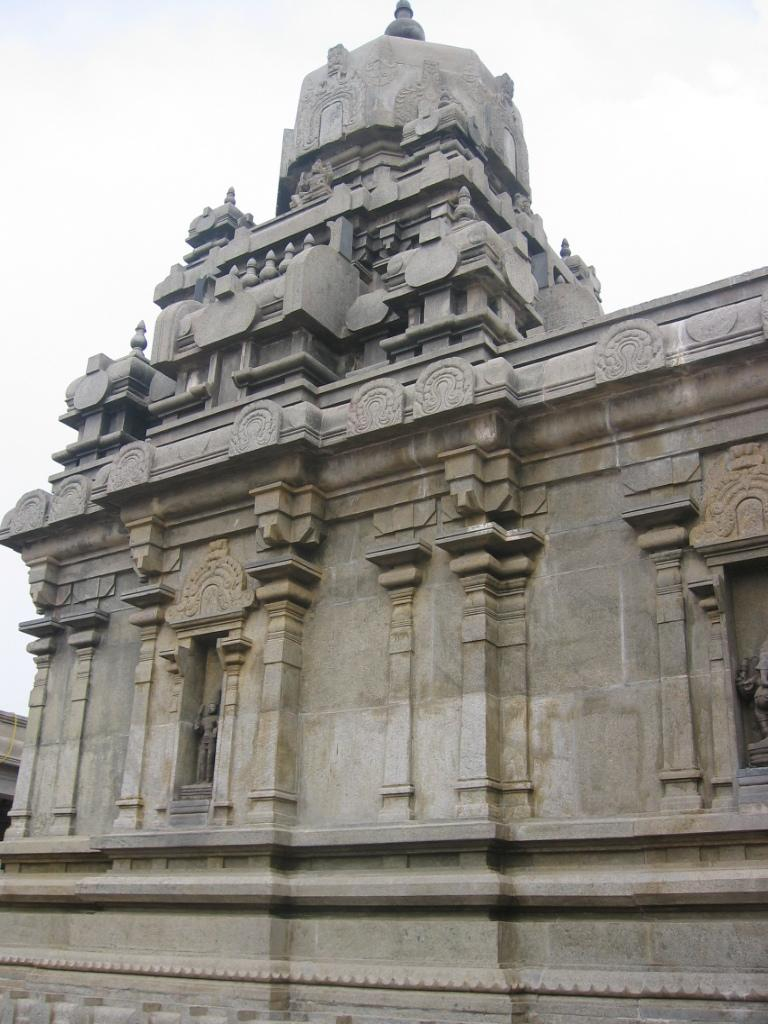What is the main subject of the picture? The main subject of the picture is a monument. What can be seen in the sky in the image? The sky and clouds are visible at the top of the image. Where are the statues located in the image? The statues are on the wall beside the pillars on the right side of the image. How many dogs are sitting on the monument in the image? There are no dogs present on the monument in the image. What type of lipstick is the statue wearing in the image? There are no statues wearing lipstick in the image; the statues are on the wall beside the pillars. 